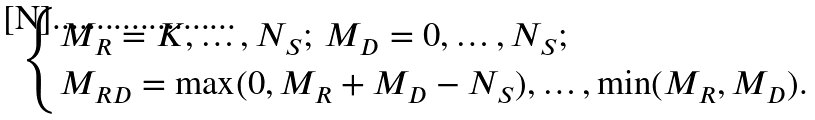Convert formula to latex. <formula><loc_0><loc_0><loc_500><loc_500>\begin{cases} M _ { R } = K , \dots , N _ { S } ; \, M _ { D } = 0 , \dots , N _ { S } ; \\ M _ { R D } = \max ( 0 , M _ { R } + M _ { D } - N _ { S } ) , \dots , \min ( M _ { R } , M _ { D } ) . \end{cases}</formula> 